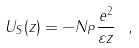<formula> <loc_0><loc_0><loc_500><loc_500>U _ { S } ( z ) = - N _ { P } \frac { e ^ { 2 } } { \varepsilon z } \ ,</formula> 